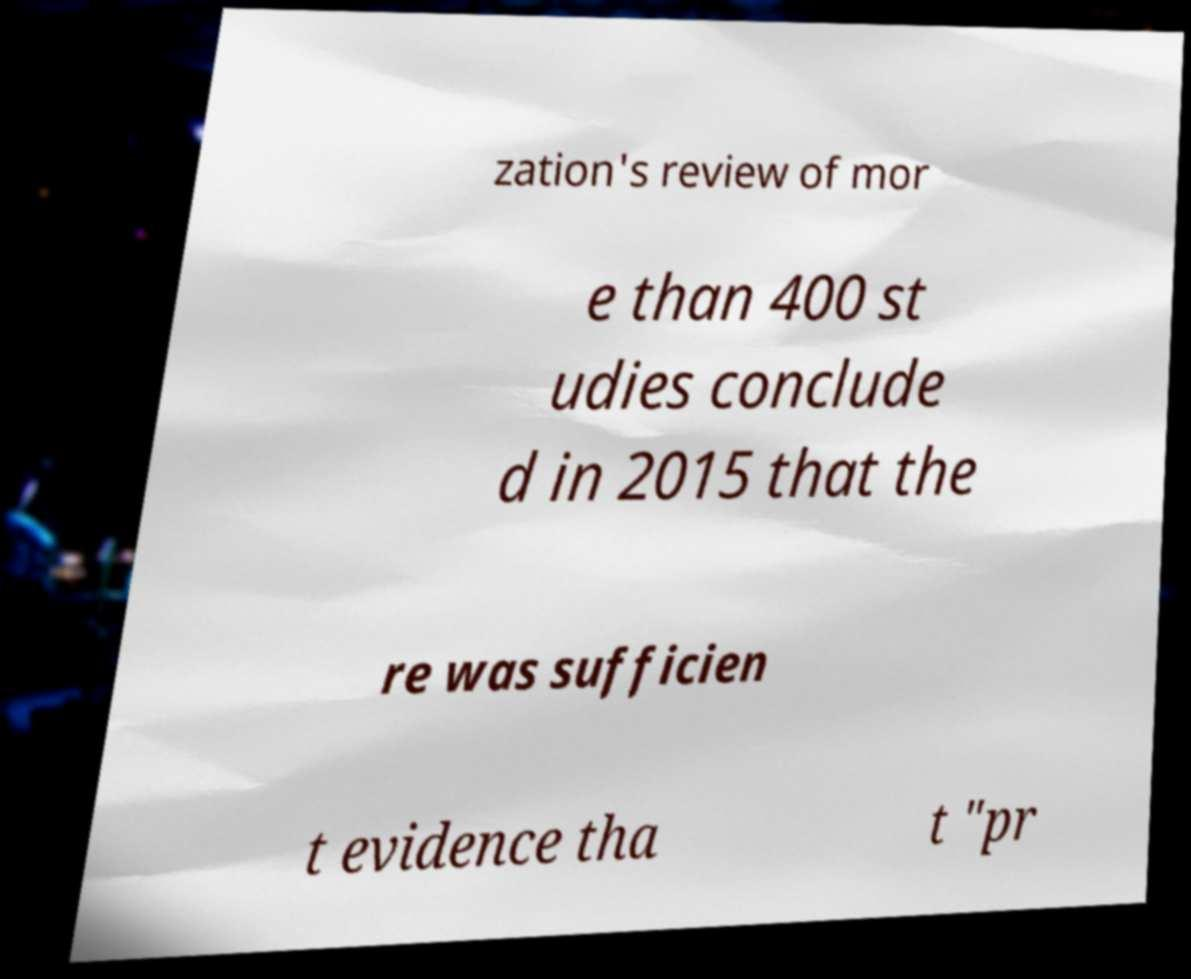For documentation purposes, I need the text within this image transcribed. Could you provide that? zation's review of mor e than 400 st udies conclude d in 2015 that the re was sufficien t evidence tha t "pr 